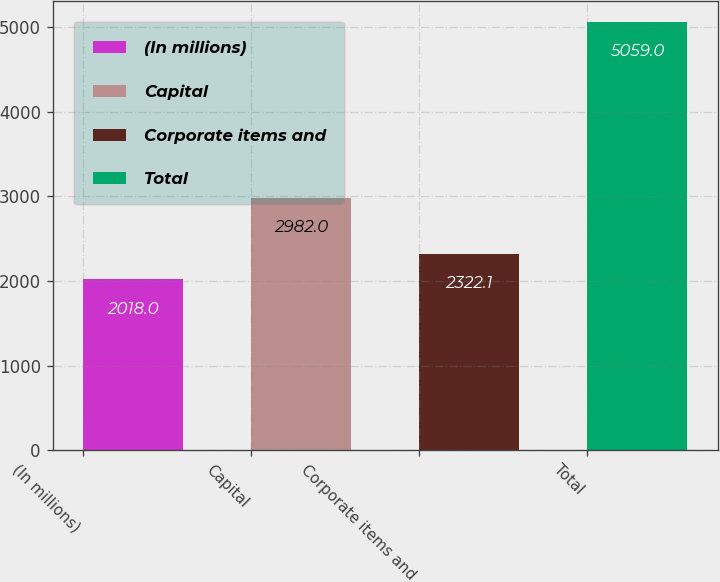Convert chart. <chart><loc_0><loc_0><loc_500><loc_500><bar_chart><fcel>(In millions)<fcel>Capital<fcel>Corporate items and<fcel>Total<nl><fcel>2018<fcel>2982<fcel>2322.1<fcel>5059<nl></chart> 